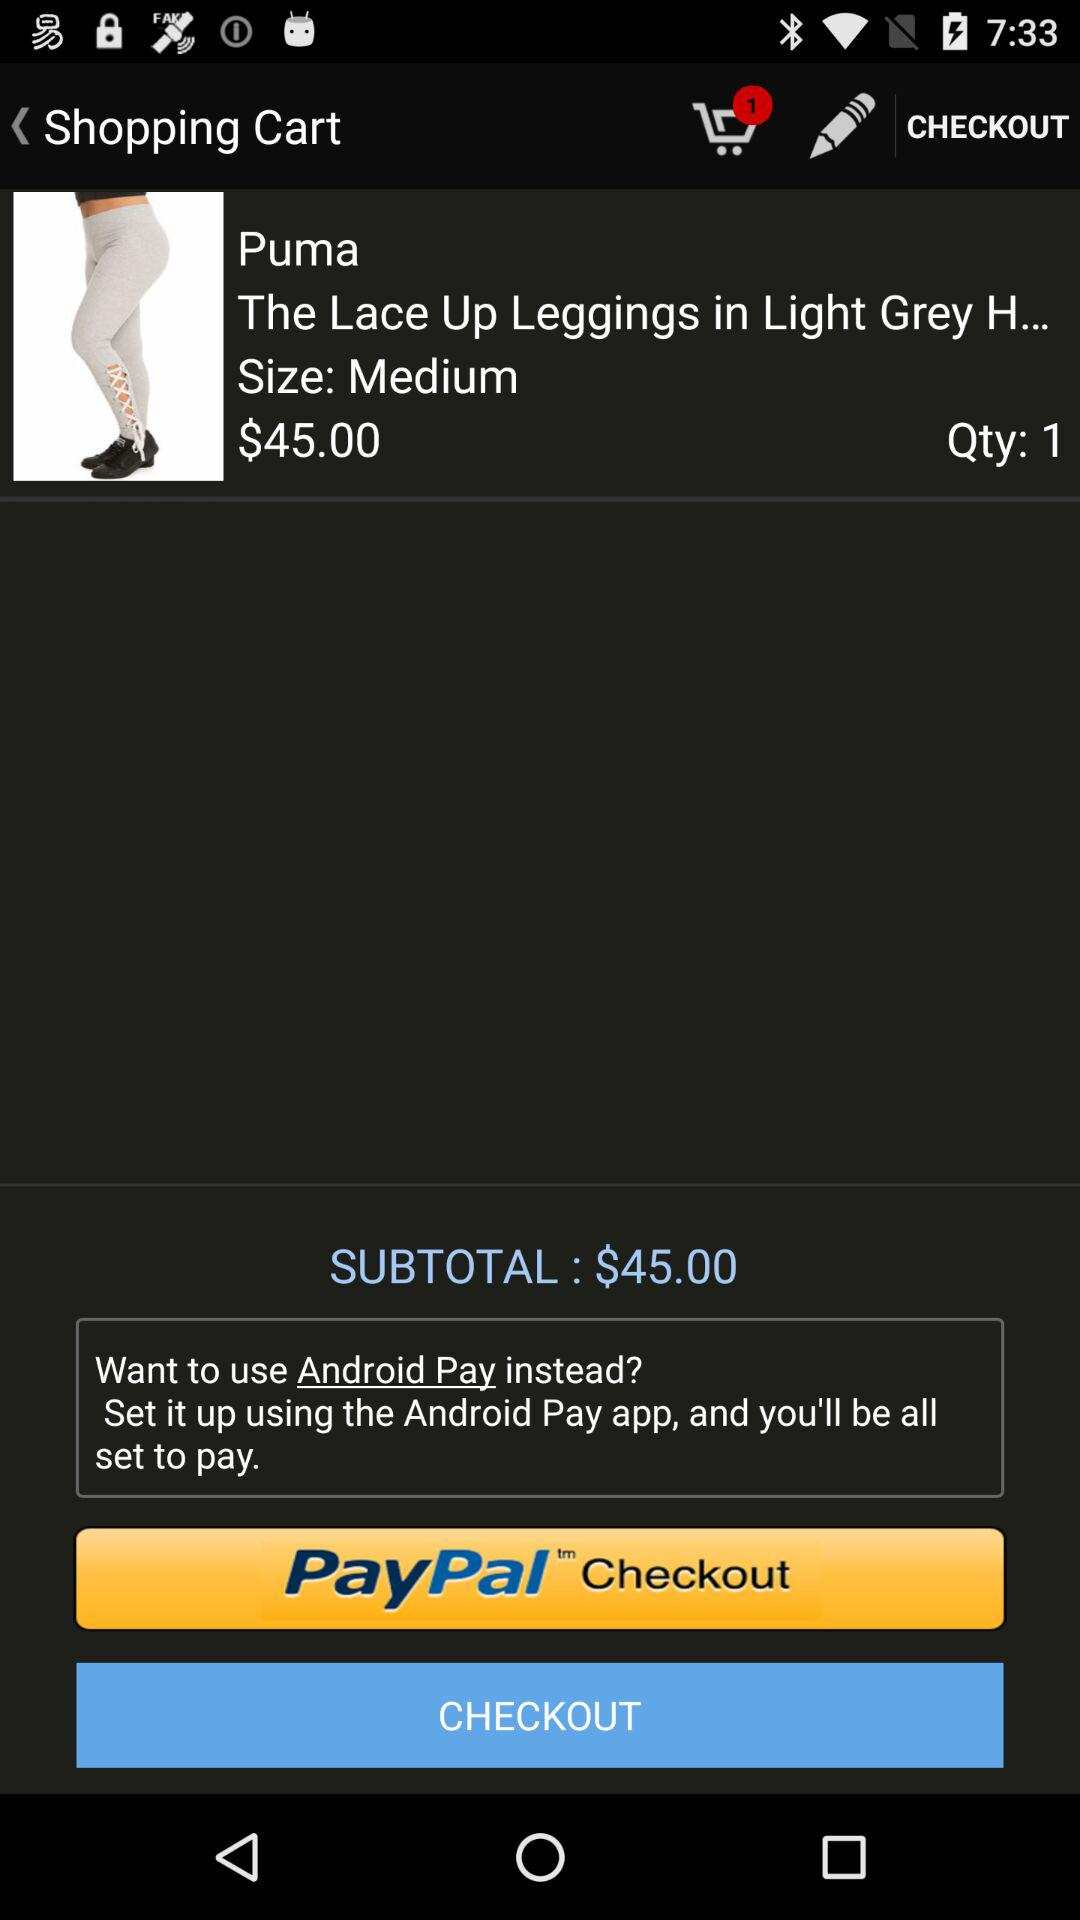Through what application can we pay the amount? You can pay the amount through "PayPal". 